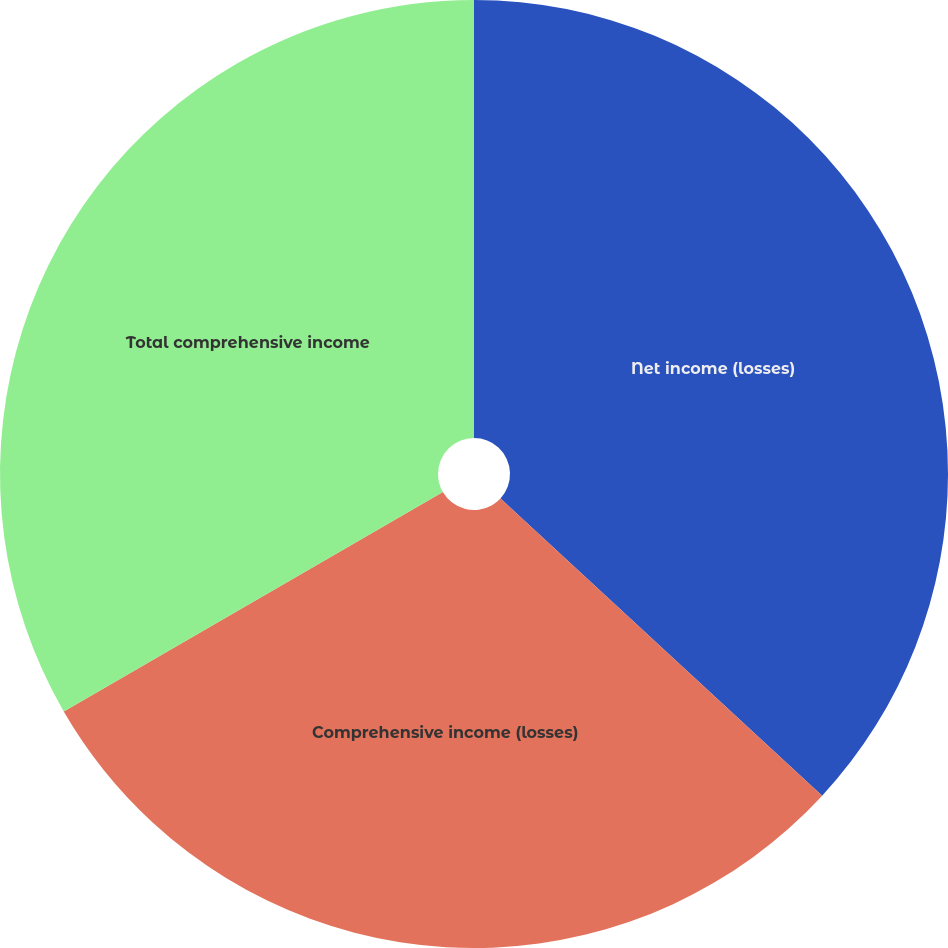<chart> <loc_0><loc_0><loc_500><loc_500><pie_chart><fcel>Net income (losses)<fcel>Comprehensive income (losses)<fcel>Total comprehensive income<nl><fcel>36.87%<fcel>29.78%<fcel>33.35%<nl></chart> 